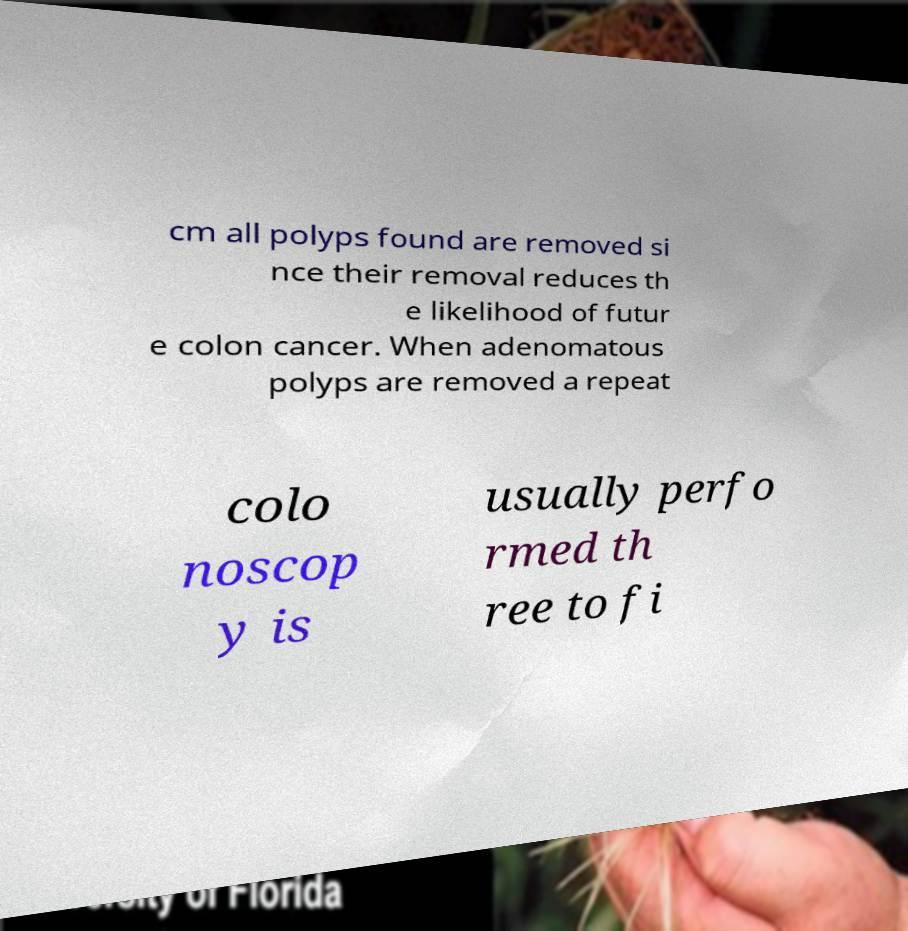Could you assist in decoding the text presented in this image and type it out clearly? cm all polyps found are removed si nce their removal reduces th e likelihood of futur e colon cancer. When adenomatous polyps are removed a repeat colo noscop y is usually perfo rmed th ree to fi 